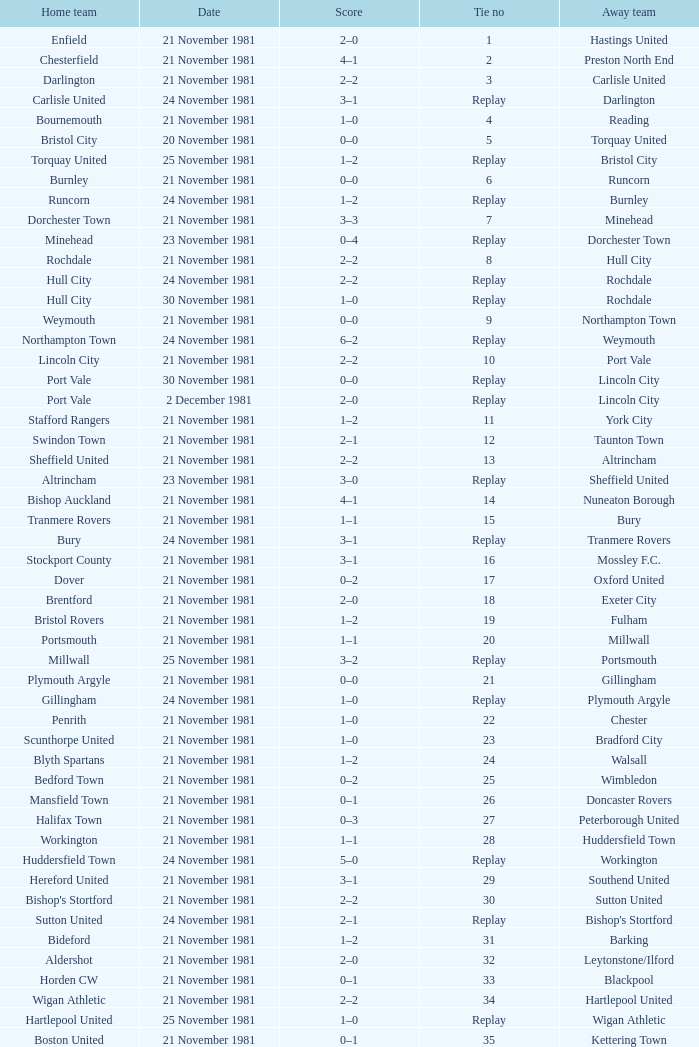On what date was tie number 4? 21 November 1981. 